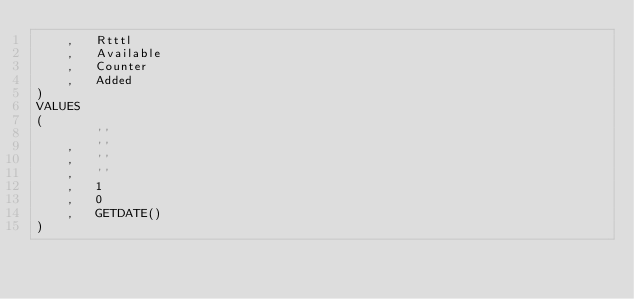<code> <loc_0><loc_0><loc_500><loc_500><_SQL_>	,	Rtttl
	,	Available
	,	Counter
	,	Added
)
VALUES
(
		''
	,	''
	,	''
	,	''
	,	1
	,	0
	,	GETDATE()
)</code> 